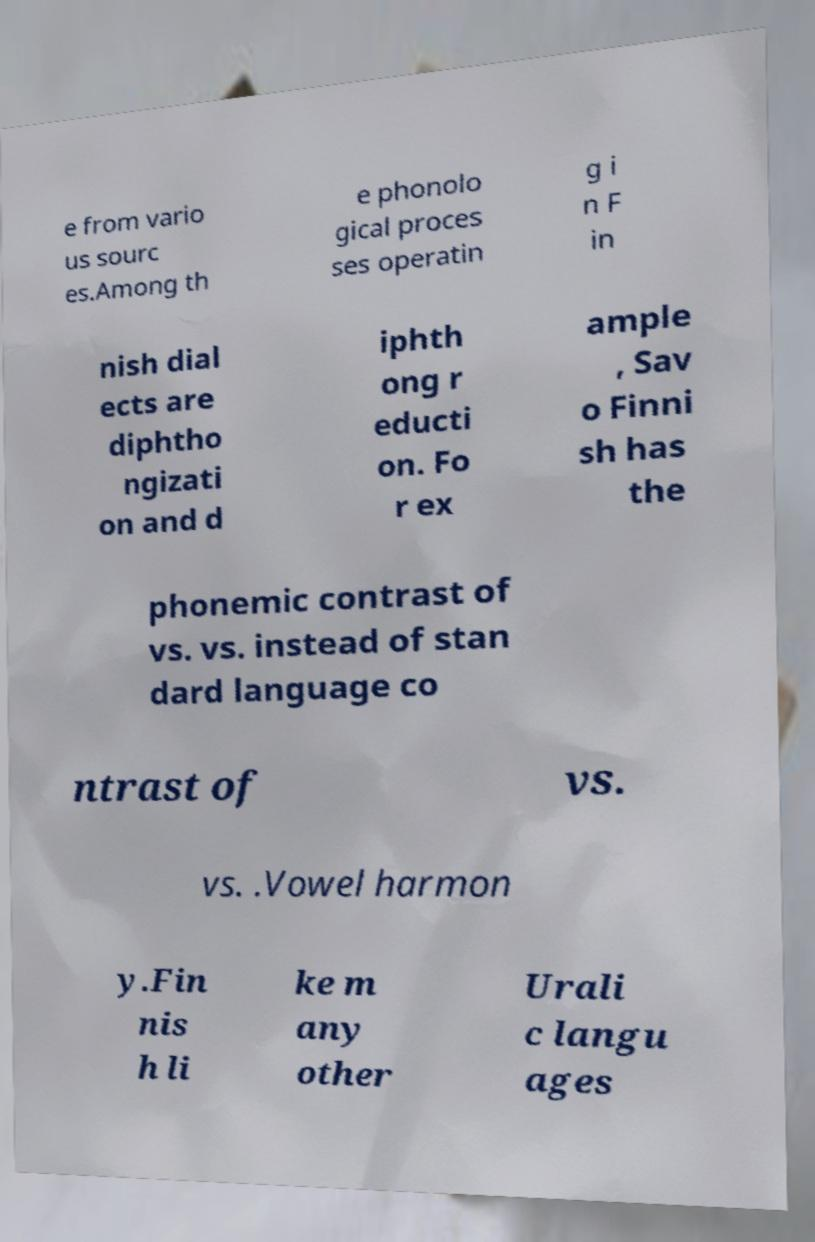Could you assist in decoding the text presented in this image and type it out clearly? e from vario us sourc es.Among th e phonolo gical proces ses operatin g i n F in nish dial ects are diphtho ngizati on and d iphth ong r educti on. Fo r ex ample , Sav o Finni sh has the phonemic contrast of vs. vs. instead of stan dard language co ntrast of vs. vs. .Vowel harmon y.Fin nis h li ke m any other Urali c langu ages 